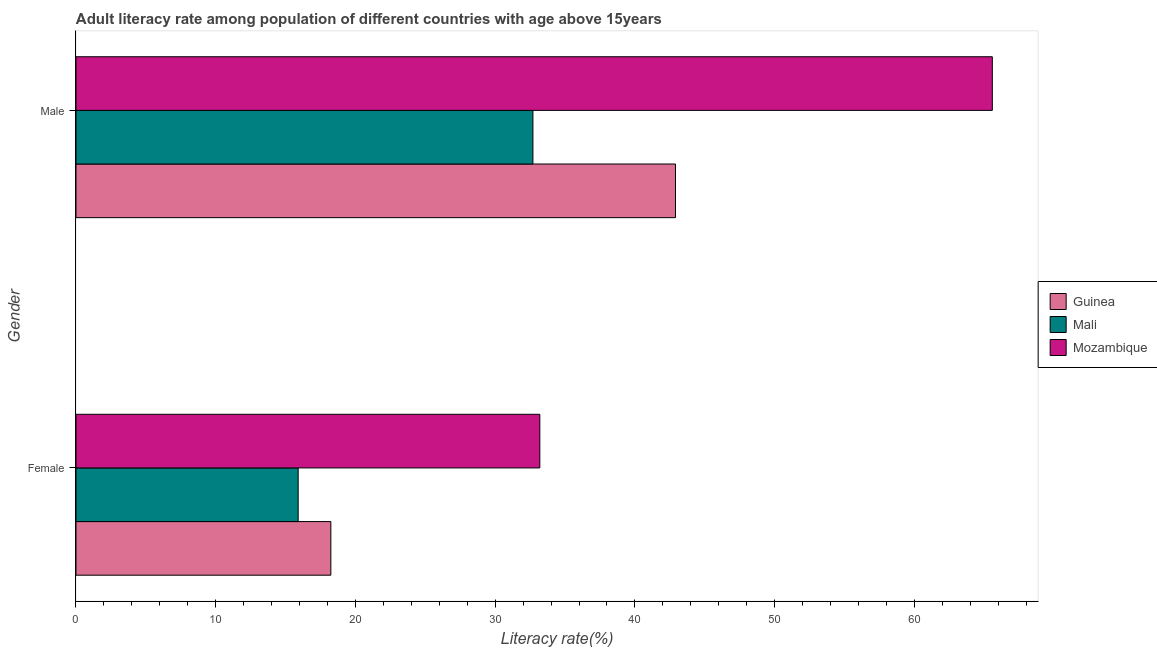How many different coloured bars are there?
Offer a very short reply. 3. How many groups of bars are there?
Your answer should be compact. 2. Are the number of bars per tick equal to the number of legend labels?
Offer a very short reply. Yes. How many bars are there on the 2nd tick from the top?
Give a very brief answer. 3. What is the label of the 1st group of bars from the top?
Keep it short and to the point. Male. What is the male adult literacy rate in Guinea?
Your answer should be compact. 42.9. Across all countries, what is the maximum female adult literacy rate?
Provide a short and direct response. 33.19. Across all countries, what is the minimum male adult literacy rate?
Your response must be concise. 32.7. In which country was the female adult literacy rate maximum?
Keep it short and to the point. Mozambique. In which country was the female adult literacy rate minimum?
Your answer should be compact. Mali. What is the total female adult literacy rate in the graph?
Your answer should be very brief. 67.33. What is the difference between the male adult literacy rate in Guinea and that in Mali?
Offer a very short reply. 10.2. What is the difference between the male adult literacy rate in Mali and the female adult literacy rate in Mozambique?
Make the answer very short. -0.49. What is the average female adult literacy rate per country?
Ensure brevity in your answer.  22.44. What is the difference between the male adult literacy rate and female adult literacy rate in Mali?
Provide a short and direct response. 16.8. What is the ratio of the female adult literacy rate in Mozambique to that in Guinea?
Make the answer very short. 1.82. In how many countries, is the male adult literacy rate greater than the average male adult literacy rate taken over all countries?
Offer a very short reply. 1. What does the 1st bar from the top in Female represents?
Provide a succinct answer. Mozambique. What does the 1st bar from the bottom in Male represents?
Give a very brief answer. Guinea. Does the graph contain any zero values?
Offer a terse response. No. Does the graph contain grids?
Give a very brief answer. No. How are the legend labels stacked?
Keep it short and to the point. Vertical. What is the title of the graph?
Your answer should be very brief. Adult literacy rate among population of different countries with age above 15years. Does "Marshall Islands" appear as one of the legend labels in the graph?
Give a very brief answer. No. What is the label or title of the X-axis?
Offer a very short reply. Literacy rate(%). What is the Literacy rate(%) of Guinea in Female?
Keep it short and to the point. 18.24. What is the Literacy rate(%) in Mali in Female?
Make the answer very short. 15.9. What is the Literacy rate(%) in Mozambique in Female?
Keep it short and to the point. 33.19. What is the Literacy rate(%) in Guinea in Male?
Offer a terse response. 42.9. What is the Literacy rate(%) of Mali in Male?
Ensure brevity in your answer.  32.7. What is the Literacy rate(%) of Mozambique in Male?
Make the answer very short. 65.58. Across all Gender, what is the maximum Literacy rate(%) in Guinea?
Your answer should be compact. 42.9. Across all Gender, what is the maximum Literacy rate(%) of Mali?
Offer a terse response. 32.7. Across all Gender, what is the maximum Literacy rate(%) of Mozambique?
Your response must be concise. 65.58. Across all Gender, what is the minimum Literacy rate(%) in Guinea?
Make the answer very short. 18.24. Across all Gender, what is the minimum Literacy rate(%) in Mali?
Ensure brevity in your answer.  15.9. Across all Gender, what is the minimum Literacy rate(%) of Mozambique?
Give a very brief answer. 33.19. What is the total Literacy rate(%) of Guinea in the graph?
Give a very brief answer. 61.14. What is the total Literacy rate(%) of Mali in the graph?
Ensure brevity in your answer.  48.6. What is the total Literacy rate(%) in Mozambique in the graph?
Provide a short and direct response. 98.77. What is the difference between the Literacy rate(%) of Guinea in Female and that in Male?
Your answer should be very brief. -24.66. What is the difference between the Literacy rate(%) of Mali in Female and that in Male?
Provide a succinct answer. -16.8. What is the difference between the Literacy rate(%) in Mozambique in Female and that in Male?
Offer a terse response. -32.38. What is the difference between the Literacy rate(%) in Guinea in Female and the Literacy rate(%) in Mali in Male?
Your response must be concise. -14.46. What is the difference between the Literacy rate(%) in Guinea in Female and the Literacy rate(%) in Mozambique in Male?
Offer a terse response. -47.34. What is the difference between the Literacy rate(%) in Mali in Female and the Literacy rate(%) in Mozambique in Male?
Your response must be concise. -49.68. What is the average Literacy rate(%) of Guinea per Gender?
Your answer should be very brief. 30.57. What is the average Literacy rate(%) of Mali per Gender?
Your response must be concise. 24.3. What is the average Literacy rate(%) of Mozambique per Gender?
Ensure brevity in your answer.  49.39. What is the difference between the Literacy rate(%) in Guinea and Literacy rate(%) in Mali in Female?
Offer a very short reply. 2.34. What is the difference between the Literacy rate(%) in Guinea and Literacy rate(%) in Mozambique in Female?
Keep it short and to the point. -14.96. What is the difference between the Literacy rate(%) in Mali and Literacy rate(%) in Mozambique in Female?
Keep it short and to the point. -17.29. What is the difference between the Literacy rate(%) of Guinea and Literacy rate(%) of Mali in Male?
Offer a very short reply. 10.2. What is the difference between the Literacy rate(%) of Guinea and Literacy rate(%) of Mozambique in Male?
Give a very brief answer. -22.67. What is the difference between the Literacy rate(%) of Mali and Literacy rate(%) of Mozambique in Male?
Keep it short and to the point. -32.88. What is the ratio of the Literacy rate(%) of Guinea in Female to that in Male?
Give a very brief answer. 0.43. What is the ratio of the Literacy rate(%) of Mali in Female to that in Male?
Give a very brief answer. 0.49. What is the ratio of the Literacy rate(%) of Mozambique in Female to that in Male?
Provide a succinct answer. 0.51. What is the difference between the highest and the second highest Literacy rate(%) of Guinea?
Give a very brief answer. 24.66. What is the difference between the highest and the second highest Literacy rate(%) in Mali?
Ensure brevity in your answer.  16.8. What is the difference between the highest and the second highest Literacy rate(%) of Mozambique?
Give a very brief answer. 32.38. What is the difference between the highest and the lowest Literacy rate(%) in Guinea?
Your response must be concise. 24.66. What is the difference between the highest and the lowest Literacy rate(%) of Mozambique?
Your answer should be compact. 32.38. 